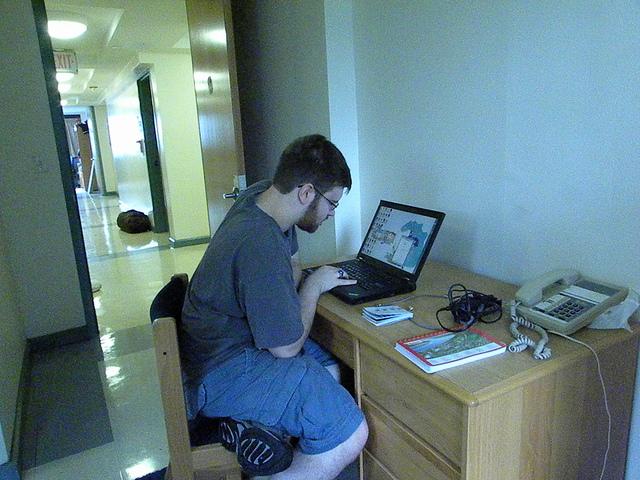Are there papers on the desk?
Short answer required. No. What kind of computer?
Give a very brief answer. Laptop. What is the man looking for?
Give a very brief answer. Information. What's outside the door in the hall?
Answer briefly. Bag. Is the door open?
Short answer required. Yes. Where are gray squares?
Give a very brief answer. Floor. How many books are there?
Write a very short answer. 1. 